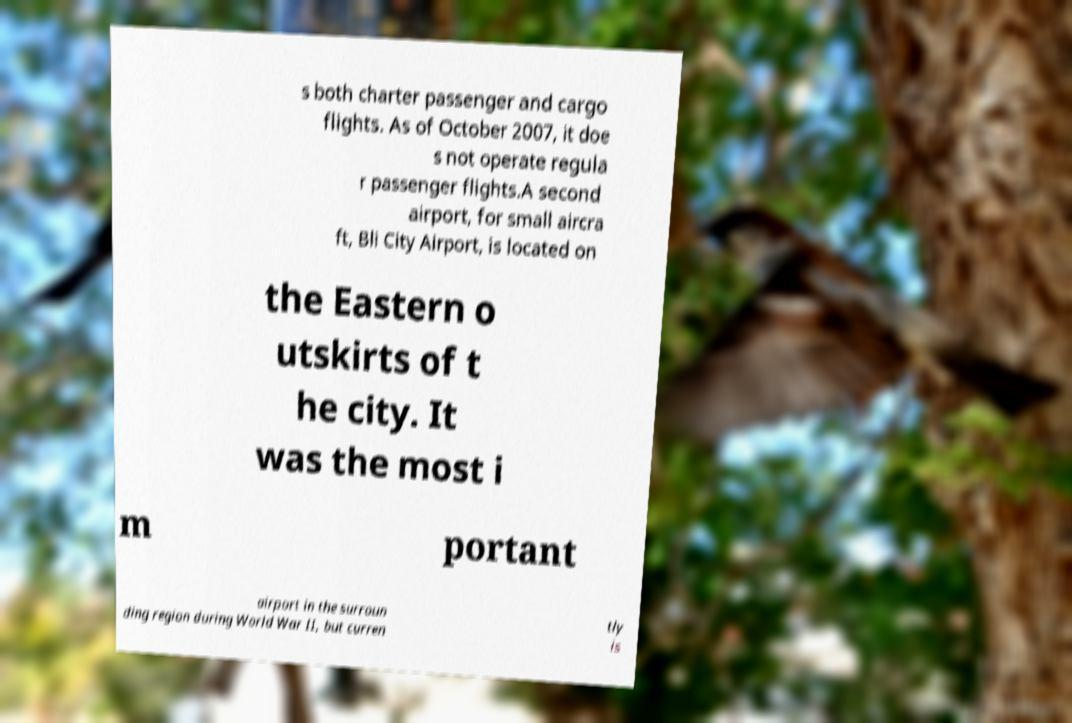Please read and relay the text visible in this image. What does it say? s both charter passenger and cargo flights. As of October 2007, it doe s not operate regula r passenger flights.A second airport, for small aircra ft, Bli City Airport, is located on the Eastern o utskirts of t he city. It was the most i m portant airport in the surroun ding region during World War II, but curren tly is 